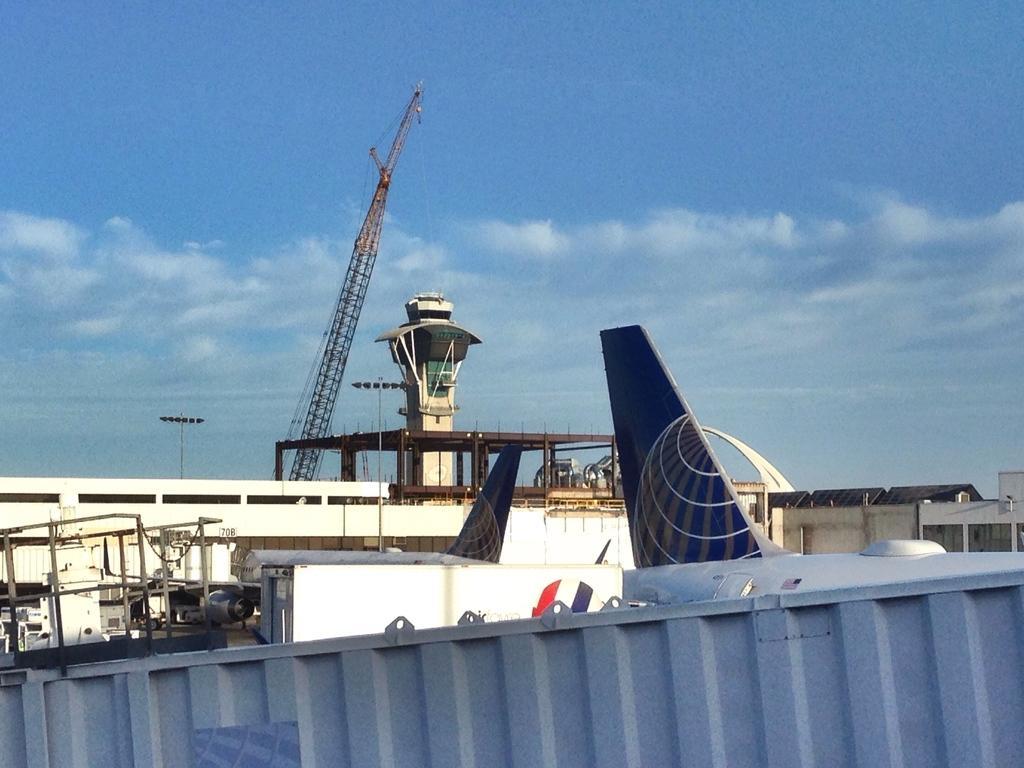Describe this image in one or two sentences. In this image, we can see a few airways. We can see a crane and the ground with some objects. We can also see a container and a few buildings. We can see some poles and the sky with clouds. 